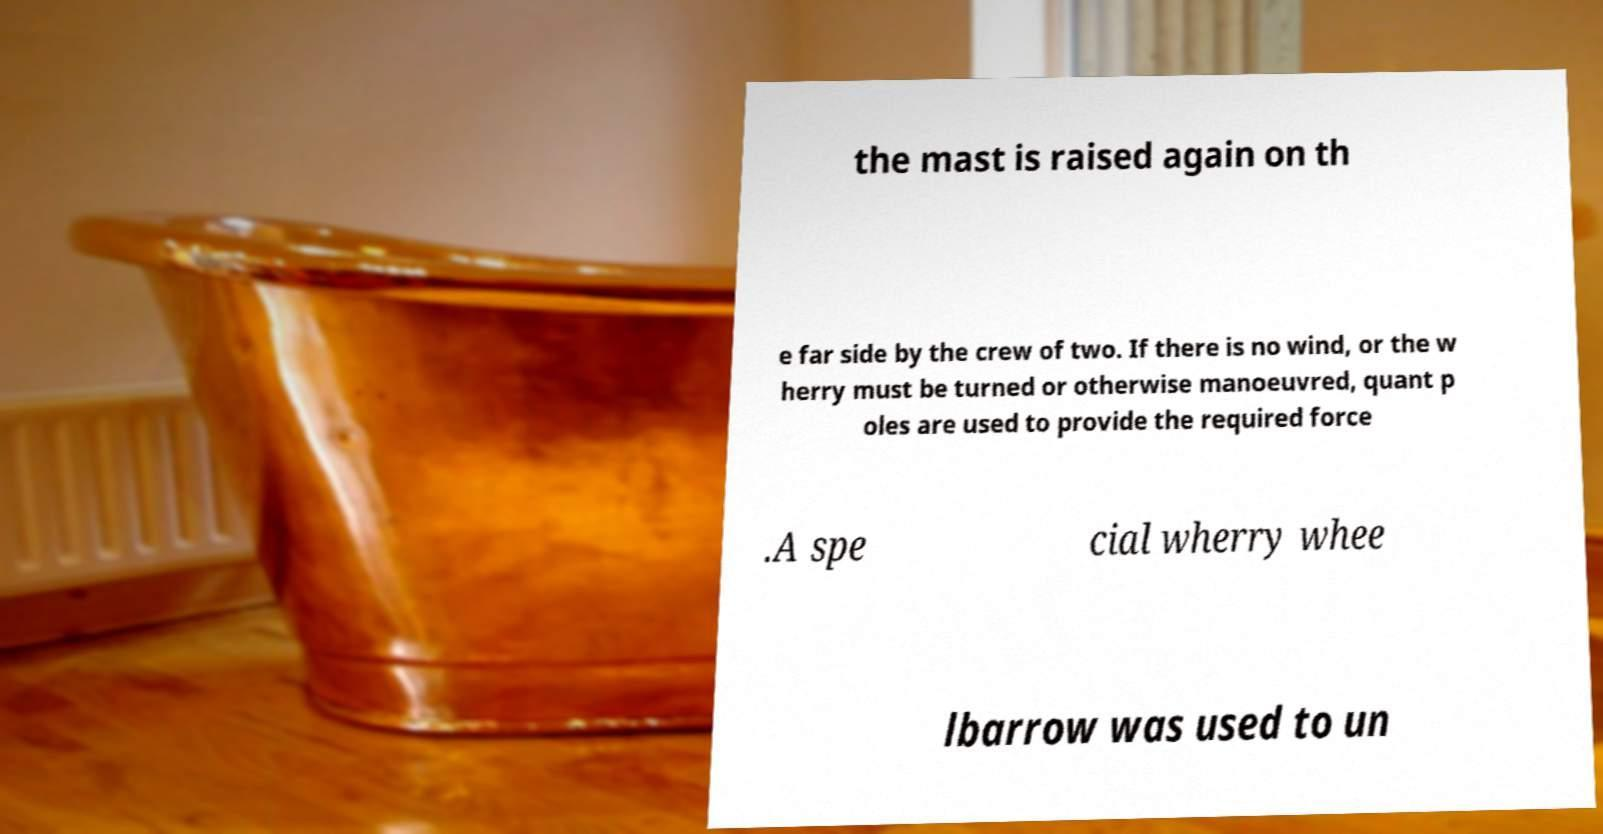There's text embedded in this image that I need extracted. Can you transcribe it verbatim? the mast is raised again on th e far side by the crew of two. If there is no wind, or the w herry must be turned or otherwise manoeuvred, quant p oles are used to provide the required force .A spe cial wherry whee lbarrow was used to un 